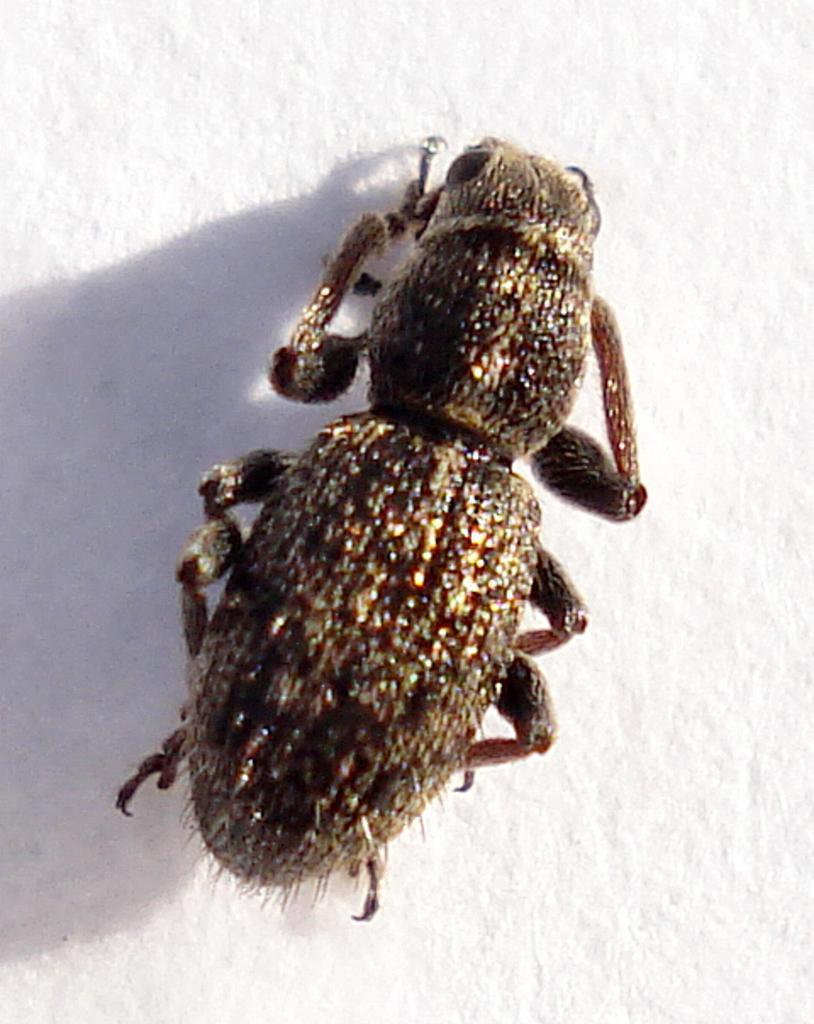Can you describe this image briefly? In the center of the image we can see an insect is present on the surface. 